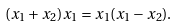Convert formula to latex. <formula><loc_0><loc_0><loc_500><loc_500>( x _ { 1 } + x _ { 2 } ) x _ { 1 } = x _ { 1 } ( x _ { 1 } - x _ { 2 } ) .</formula> 